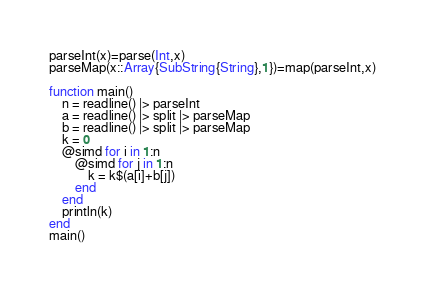Convert code to text. <code><loc_0><loc_0><loc_500><loc_500><_Julia_>parseInt(x)=parse(Int,x)
parseMap(x::Array{SubString{String},1})=map(parseInt,x)

function main()
	n = readline() |> parseInt
	a = readline() |> split |> parseMap
	b = readline() |> split |> parseMap
	k = 0
	@simd for i in 1:n
		@simd for j in 1:n
			k = k$(a[i]+b[j])
		end
	end
	println(k)
end
main()
</code> 